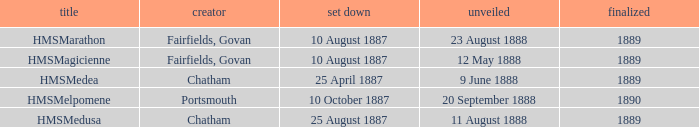When did chatham complete the Hmsmedusa? 1889.0. 